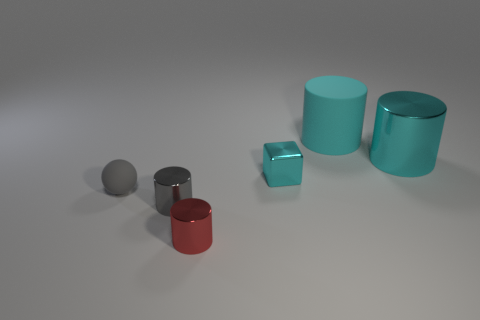Imagine these objects are part of a child's playset. Which educational concepts could they be used to teach? These objects could be an excellent resource for teaching basic geometry, color theory, and material properties. Children could learn about shapes and volume by examining the cubes and cylinders, concept of reflection and texture using the shiny and matte surfaces, and primary colors with the red and blue hues. 